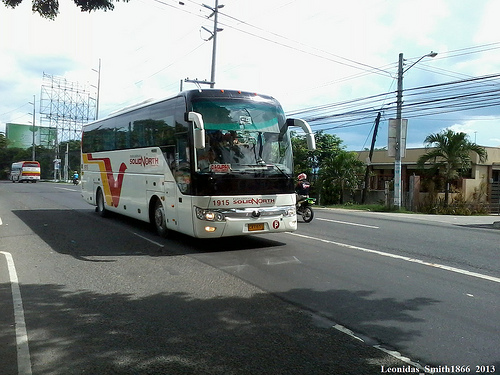Please provide a short description for this region: [0.14, 0.32, 0.58, 0.63]. A bus with white, yellow, and red colors. 